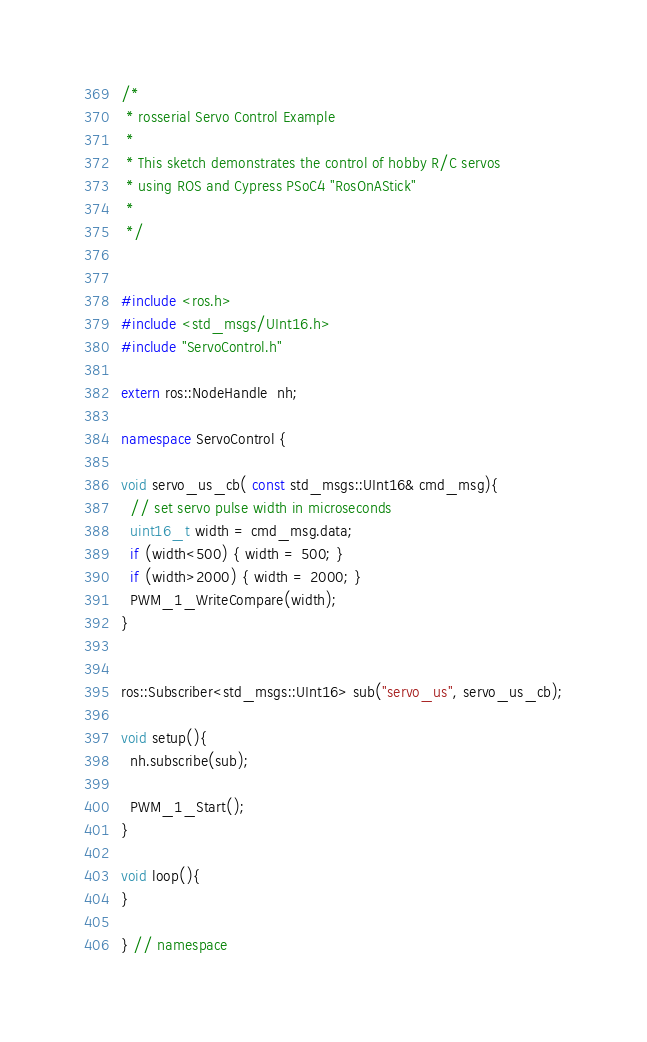<code> <loc_0><loc_0><loc_500><loc_500><_C++_>/*
 * rosserial Servo Control Example
 *
 * This sketch demonstrates the control of hobby R/C servos
 * using ROS and Cypress PSoC4 "RosOnAStick"
 * 
 */


#include <ros.h>
#include <std_msgs/UInt16.h>
#include "ServoControl.h"

extern ros::NodeHandle  nh;

namespace ServoControl {

void servo_us_cb( const std_msgs::UInt16& cmd_msg){
  // set servo pulse width in microseconds
  uint16_t width = cmd_msg.data;
  if (width<500) { width = 500; }
  if (width>2000) { width = 2000; }
  PWM_1_WriteCompare(width); 
}


ros::Subscriber<std_msgs::UInt16> sub("servo_us", servo_us_cb);

void setup(){
  nh.subscribe(sub);
  
  PWM_1_Start();
}

void loop(){
}

} // namespace
</code> 